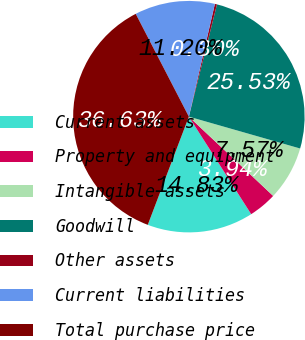<chart> <loc_0><loc_0><loc_500><loc_500><pie_chart><fcel>Current assets<fcel>Property and equipment<fcel>Intangible assets<fcel>Goodwill<fcel>Other assets<fcel>Current liabilities<fcel>Total purchase price<nl><fcel>14.83%<fcel>3.94%<fcel>7.57%<fcel>25.53%<fcel>0.3%<fcel>11.2%<fcel>36.63%<nl></chart> 